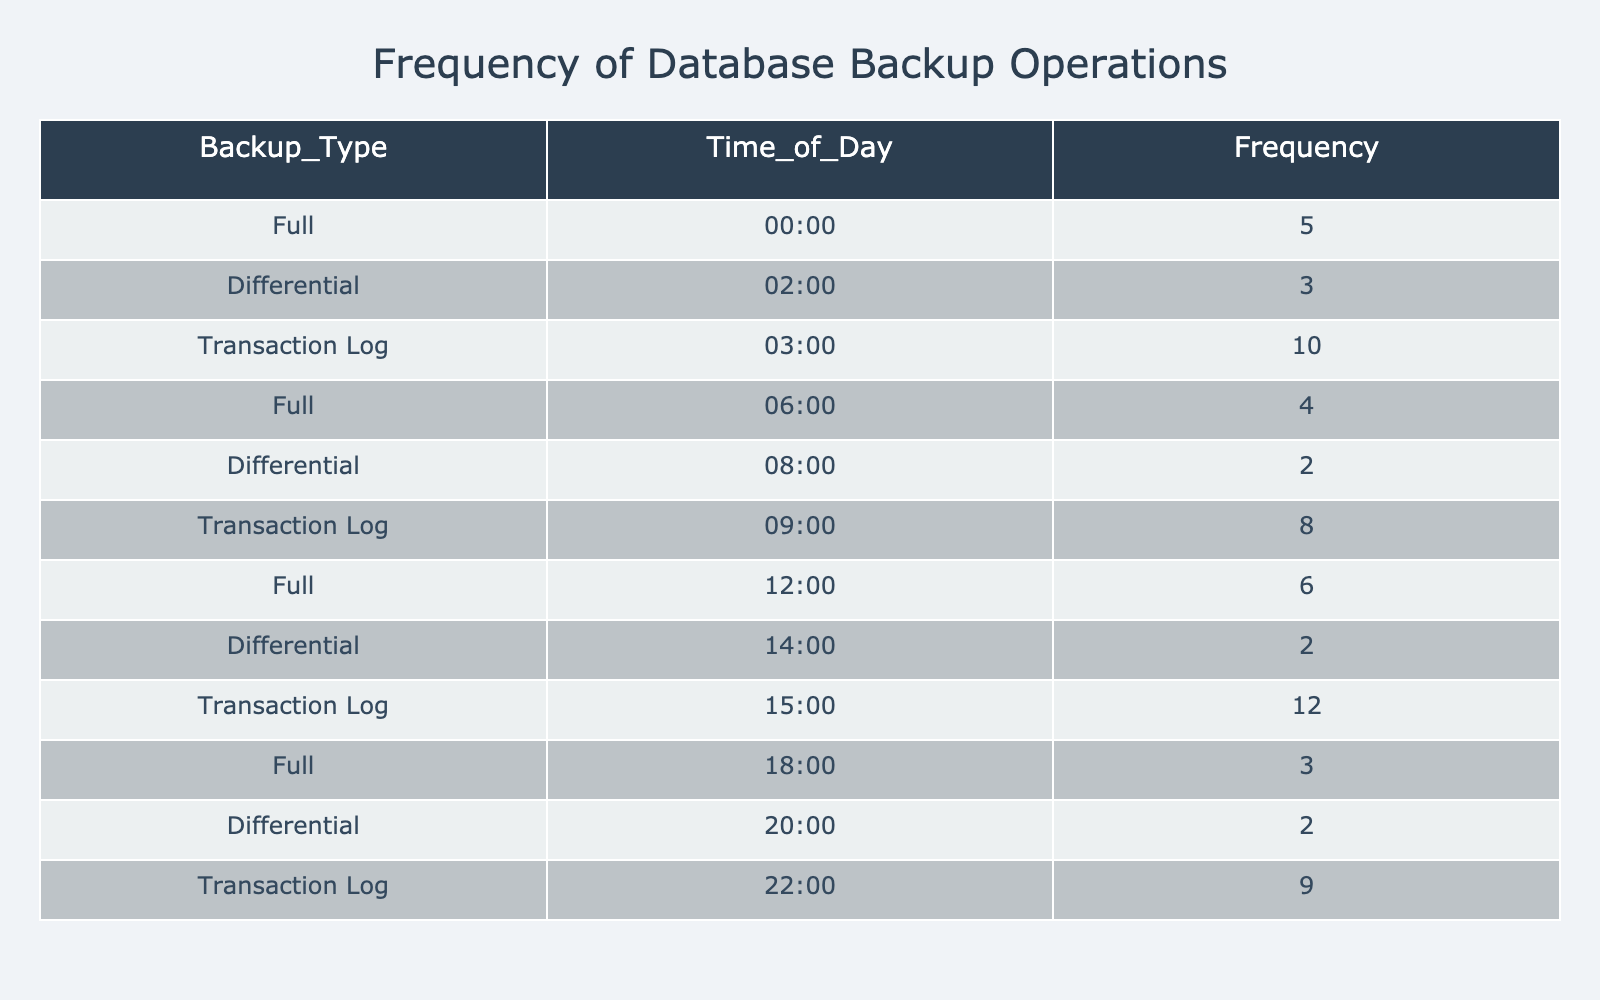What is the frequency of Full backups at 00:00? The table lists the frequency for each backup type at different times. For Full backups, at 00:00, the frequency value is directly provided as 5.
Answer: 5 How many Total Transaction Log backups were performed across all times? We can see the frequencies for Transaction Log backups at three different times: 10 at 03:00, 8 at 09:00, and 12 at 15:00. Adding these together gives us 10 + 8 + 12 = 30.
Answer: 30 Is there a Differential backup at 20:00? By examining the table, we can find the frequency listed for Differential backups at 20:00 is 2, showing that there was a Differential backup performed at that time.
Answer: Yes Which backup type has the highest frequency and what is that frequency? First, we look at the frequency values for each backup type. The highest frequency value is 12 for Transaction Log backups at 15:00. This means Transaction Log is the backup type with the highest frequency.
Answer: Transaction Log, 12 What is the average frequency of Differential backups? To calculate the average frequency for Differential backups, we first identify their frequencies: 3 at 02:00, 2 at 08:00, and 2 at 14:00. Adding these gives us 3 + 2 + 2 = 7. There are 3 data points, so the average frequency is 7 divided by 3, which equals approximately 2.33.
Answer: 2.33 What is the frequency of backups at 12:00? The table provides the frequency of backups at 12:00, specifically for Full backups, which is listed as 6. Therefore, at this time, the frequency of backups is 6 for the Full backup type.
Answer: 6 How many more Transaction Log backups were performed than Full backups during the day? We first calculate the total frequency for Transaction Log backups: 10 (03:00) + 8 (09:00) + 12 (15:00) = 30. Then we calculate the total for Full backups: 5 (00:00) + 4 (06:00) + 6 (12:00) + 3 (18:00) = 18. Subtracting these totals gives us 30 - 18 = 12 more Transaction Log backups than Full backups.
Answer: 12 Are there more Full backups performed during night hours than in the morning? Looking at the time slots, Full backups were performed at 00:00 (5), 06:00 (4), and 18:00 (3). The night hours (00:00) give us a total of 5, while in the morning (06:00), there were 4. Hence, since 5 is greater than 4, there were more Full backups during the night.
Answer: Yes What is the total frequency of all backups at 18:00? The table lists backups at 18:00, which shows the frequency for Full backups is 3. There are no other backup types at 18:00; thus, the total frequency for all backups at this time is simply 3.
Answer: 3 